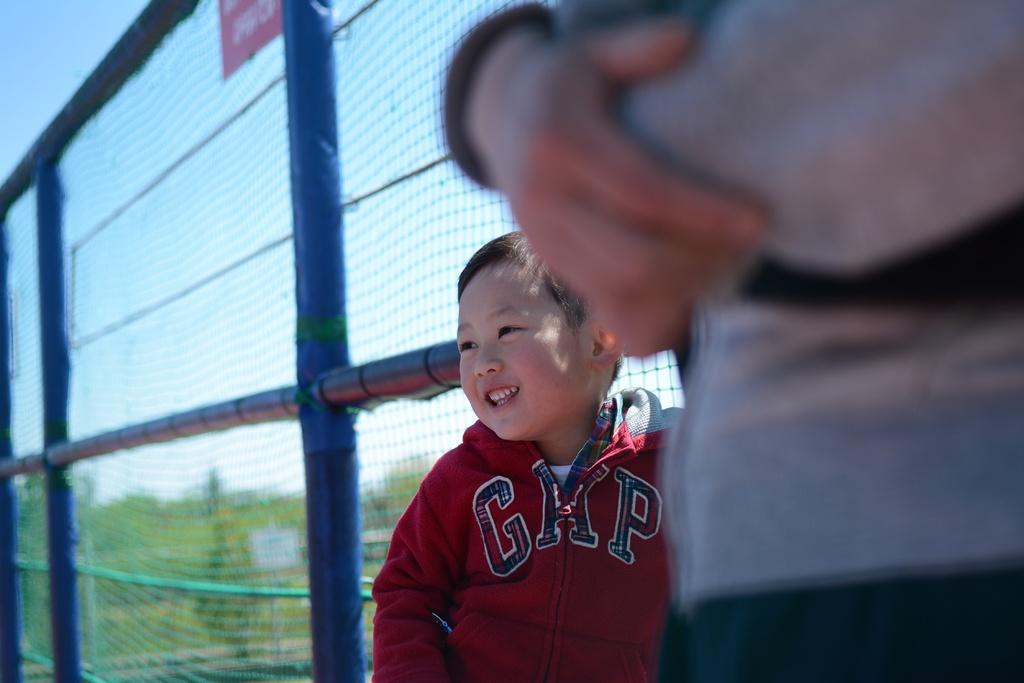<image>
Relay a brief, clear account of the picture shown. A little boy in a GAP zip-up shirt stands next to a mesh fence. 